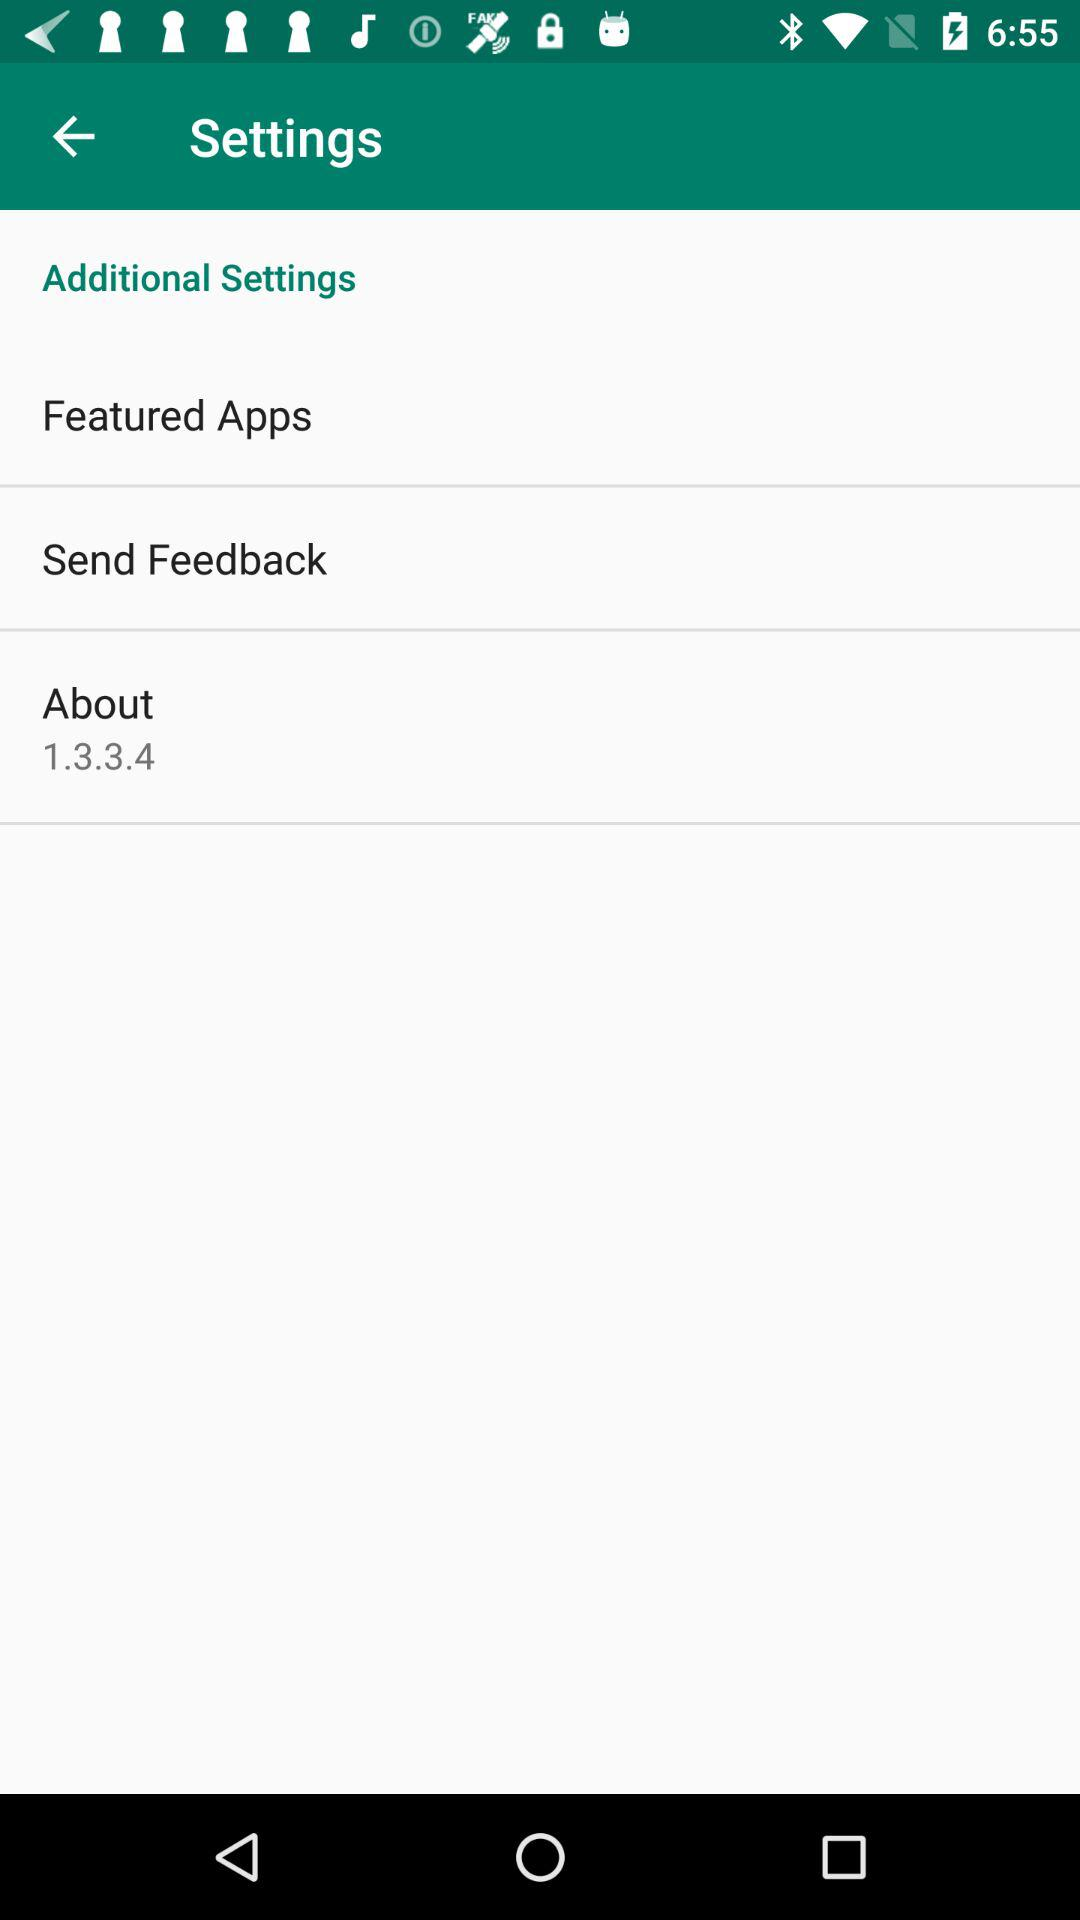What is the version number of the app?
Answer the question using a single word or phrase. 1.3.3.4 